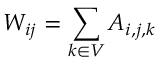Convert formula to latex. <formula><loc_0><loc_0><loc_500><loc_500>W _ { i j } = \sum _ { k \in V } A _ { i , j , k }</formula> 